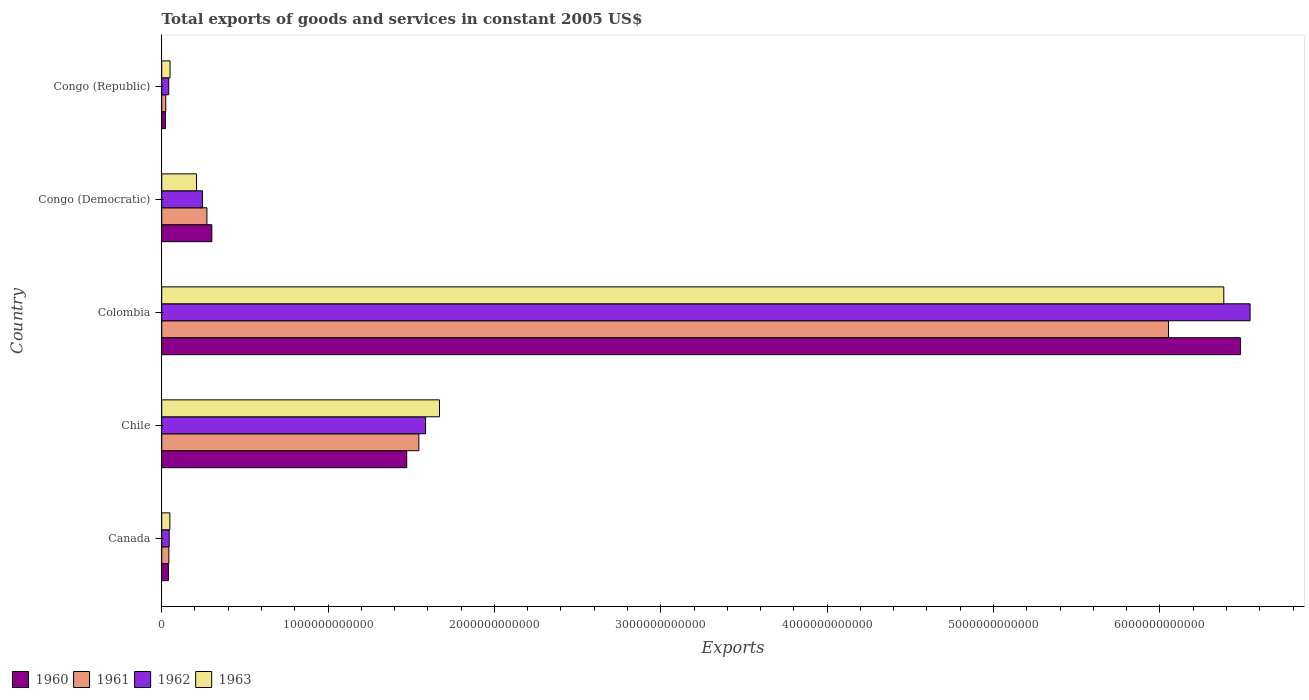How many bars are there on the 1st tick from the bottom?
Make the answer very short. 4. What is the label of the 2nd group of bars from the top?
Keep it short and to the point. Congo (Democratic). In how many cases, is the number of bars for a given country not equal to the number of legend labels?
Your response must be concise. 0. What is the total exports of goods and services in 1961 in Canada?
Your response must be concise. 4.29e+1. Across all countries, what is the maximum total exports of goods and services in 1961?
Keep it short and to the point. 6.05e+12. Across all countries, what is the minimum total exports of goods and services in 1962?
Ensure brevity in your answer.  4.20e+1. In which country was the total exports of goods and services in 1961 maximum?
Provide a short and direct response. Colombia. In which country was the total exports of goods and services in 1963 minimum?
Your answer should be compact. Canada. What is the total total exports of goods and services in 1961 in the graph?
Ensure brevity in your answer.  7.94e+12. What is the difference between the total exports of goods and services in 1963 in Chile and that in Colombia?
Provide a succinct answer. -4.71e+12. What is the difference between the total exports of goods and services in 1960 in Chile and the total exports of goods and services in 1961 in Congo (Republic)?
Offer a terse response. 1.45e+12. What is the average total exports of goods and services in 1960 per country?
Give a very brief answer. 1.66e+12. What is the difference between the total exports of goods and services in 1961 and total exports of goods and services in 1963 in Canada?
Offer a very short reply. -6.12e+09. In how many countries, is the total exports of goods and services in 1962 greater than 4000000000000 US$?
Your answer should be very brief. 1. What is the ratio of the total exports of goods and services in 1960 in Canada to that in Congo (Republic)?
Ensure brevity in your answer.  1.78. Is the total exports of goods and services in 1960 in Chile less than that in Congo (Republic)?
Your answer should be compact. No. What is the difference between the highest and the second highest total exports of goods and services in 1962?
Offer a terse response. 4.96e+12. What is the difference between the highest and the lowest total exports of goods and services in 1963?
Provide a short and direct response. 6.34e+12. In how many countries, is the total exports of goods and services in 1961 greater than the average total exports of goods and services in 1961 taken over all countries?
Ensure brevity in your answer.  1. What does the 2nd bar from the bottom in Congo (Republic) represents?
Offer a terse response. 1961. Are all the bars in the graph horizontal?
Offer a very short reply. Yes. How many countries are there in the graph?
Provide a short and direct response. 5. What is the difference between two consecutive major ticks on the X-axis?
Offer a very short reply. 1.00e+12. Does the graph contain any zero values?
Ensure brevity in your answer.  No. How are the legend labels stacked?
Your answer should be compact. Horizontal. What is the title of the graph?
Ensure brevity in your answer.  Total exports of goods and services in constant 2005 US$. What is the label or title of the X-axis?
Your answer should be compact. Exports. What is the label or title of the Y-axis?
Give a very brief answer. Country. What is the Exports of 1960 in Canada?
Provide a short and direct response. 4.02e+1. What is the Exports of 1961 in Canada?
Your answer should be very brief. 4.29e+1. What is the Exports of 1962 in Canada?
Keep it short and to the point. 4.49e+1. What is the Exports in 1963 in Canada?
Provide a succinct answer. 4.91e+1. What is the Exports of 1960 in Chile?
Your answer should be very brief. 1.47e+12. What is the Exports in 1961 in Chile?
Provide a succinct answer. 1.55e+12. What is the Exports of 1962 in Chile?
Ensure brevity in your answer.  1.59e+12. What is the Exports in 1963 in Chile?
Your answer should be very brief. 1.67e+12. What is the Exports in 1960 in Colombia?
Make the answer very short. 6.48e+12. What is the Exports of 1961 in Colombia?
Offer a terse response. 6.05e+12. What is the Exports of 1962 in Colombia?
Give a very brief answer. 6.54e+12. What is the Exports in 1963 in Colombia?
Ensure brevity in your answer.  6.38e+12. What is the Exports in 1960 in Congo (Democratic)?
Your response must be concise. 3.01e+11. What is the Exports of 1961 in Congo (Democratic)?
Give a very brief answer. 2.72e+11. What is the Exports in 1962 in Congo (Democratic)?
Your answer should be compact. 2.45e+11. What is the Exports of 1963 in Congo (Democratic)?
Offer a terse response. 2.09e+11. What is the Exports of 1960 in Congo (Republic)?
Your response must be concise. 2.25e+1. What is the Exports of 1961 in Congo (Republic)?
Give a very brief answer. 2.42e+1. What is the Exports in 1962 in Congo (Republic)?
Make the answer very short. 4.20e+1. What is the Exports in 1963 in Congo (Republic)?
Provide a succinct answer. 5.01e+1. Across all countries, what is the maximum Exports of 1960?
Keep it short and to the point. 6.48e+12. Across all countries, what is the maximum Exports of 1961?
Make the answer very short. 6.05e+12. Across all countries, what is the maximum Exports of 1962?
Keep it short and to the point. 6.54e+12. Across all countries, what is the maximum Exports of 1963?
Your answer should be very brief. 6.38e+12. Across all countries, what is the minimum Exports in 1960?
Your answer should be very brief. 2.25e+1. Across all countries, what is the minimum Exports of 1961?
Provide a short and direct response. 2.42e+1. Across all countries, what is the minimum Exports of 1962?
Your answer should be very brief. 4.20e+1. Across all countries, what is the minimum Exports in 1963?
Provide a succinct answer. 4.91e+1. What is the total Exports in 1960 in the graph?
Your response must be concise. 8.32e+12. What is the total Exports of 1961 in the graph?
Offer a very short reply. 7.94e+12. What is the total Exports in 1962 in the graph?
Provide a succinct answer. 8.46e+12. What is the total Exports of 1963 in the graph?
Provide a succinct answer. 8.36e+12. What is the difference between the Exports of 1960 in Canada and that in Chile?
Provide a succinct answer. -1.43e+12. What is the difference between the Exports of 1961 in Canada and that in Chile?
Keep it short and to the point. -1.50e+12. What is the difference between the Exports in 1962 in Canada and that in Chile?
Provide a succinct answer. -1.54e+12. What is the difference between the Exports of 1963 in Canada and that in Chile?
Your answer should be compact. -1.62e+12. What is the difference between the Exports of 1960 in Canada and that in Colombia?
Offer a terse response. -6.44e+12. What is the difference between the Exports of 1961 in Canada and that in Colombia?
Your answer should be very brief. -6.01e+12. What is the difference between the Exports in 1962 in Canada and that in Colombia?
Provide a succinct answer. -6.50e+12. What is the difference between the Exports in 1963 in Canada and that in Colombia?
Make the answer very short. -6.34e+12. What is the difference between the Exports of 1960 in Canada and that in Congo (Democratic)?
Your answer should be very brief. -2.61e+11. What is the difference between the Exports in 1961 in Canada and that in Congo (Democratic)?
Your answer should be compact. -2.29e+11. What is the difference between the Exports of 1962 in Canada and that in Congo (Democratic)?
Keep it short and to the point. -2.00e+11. What is the difference between the Exports of 1963 in Canada and that in Congo (Democratic)?
Offer a terse response. -1.60e+11. What is the difference between the Exports in 1960 in Canada and that in Congo (Republic)?
Give a very brief answer. 1.77e+1. What is the difference between the Exports in 1961 in Canada and that in Congo (Republic)?
Your answer should be very brief. 1.87e+1. What is the difference between the Exports in 1962 in Canada and that in Congo (Republic)?
Provide a succinct answer. 2.86e+09. What is the difference between the Exports of 1963 in Canada and that in Congo (Republic)?
Make the answer very short. -1.07e+09. What is the difference between the Exports of 1960 in Chile and that in Colombia?
Keep it short and to the point. -5.01e+12. What is the difference between the Exports in 1961 in Chile and that in Colombia?
Keep it short and to the point. -4.51e+12. What is the difference between the Exports in 1962 in Chile and that in Colombia?
Your response must be concise. -4.96e+12. What is the difference between the Exports in 1963 in Chile and that in Colombia?
Keep it short and to the point. -4.71e+12. What is the difference between the Exports in 1960 in Chile and that in Congo (Democratic)?
Offer a terse response. 1.17e+12. What is the difference between the Exports of 1961 in Chile and that in Congo (Democratic)?
Keep it short and to the point. 1.27e+12. What is the difference between the Exports of 1962 in Chile and that in Congo (Democratic)?
Your answer should be compact. 1.34e+12. What is the difference between the Exports in 1963 in Chile and that in Congo (Democratic)?
Your answer should be very brief. 1.46e+12. What is the difference between the Exports in 1960 in Chile and that in Congo (Republic)?
Offer a terse response. 1.45e+12. What is the difference between the Exports of 1961 in Chile and that in Congo (Republic)?
Provide a succinct answer. 1.52e+12. What is the difference between the Exports in 1962 in Chile and that in Congo (Republic)?
Offer a terse response. 1.54e+12. What is the difference between the Exports in 1963 in Chile and that in Congo (Republic)?
Provide a short and direct response. 1.62e+12. What is the difference between the Exports in 1960 in Colombia and that in Congo (Democratic)?
Ensure brevity in your answer.  6.18e+12. What is the difference between the Exports of 1961 in Colombia and that in Congo (Democratic)?
Provide a succinct answer. 5.78e+12. What is the difference between the Exports of 1962 in Colombia and that in Congo (Democratic)?
Your response must be concise. 6.30e+12. What is the difference between the Exports of 1963 in Colombia and that in Congo (Democratic)?
Ensure brevity in your answer.  6.17e+12. What is the difference between the Exports of 1960 in Colombia and that in Congo (Republic)?
Ensure brevity in your answer.  6.46e+12. What is the difference between the Exports of 1961 in Colombia and that in Congo (Republic)?
Offer a terse response. 6.03e+12. What is the difference between the Exports in 1962 in Colombia and that in Congo (Republic)?
Keep it short and to the point. 6.50e+12. What is the difference between the Exports of 1963 in Colombia and that in Congo (Republic)?
Make the answer very short. 6.33e+12. What is the difference between the Exports of 1960 in Congo (Democratic) and that in Congo (Republic)?
Offer a very short reply. 2.79e+11. What is the difference between the Exports in 1961 in Congo (Democratic) and that in Congo (Republic)?
Make the answer very short. 2.48e+11. What is the difference between the Exports in 1962 in Congo (Democratic) and that in Congo (Republic)?
Ensure brevity in your answer.  2.03e+11. What is the difference between the Exports in 1963 in Congo (Democratic) and that in Congo (Republic)?
Make the answer very short. 1.59e+11. What is the difference between the Exports in 1960 in Canada and the Exports in 1961 in Chile?
Ensure brevity in your answer.  -1.51e+12. What is the difference between the Exports of 1960 in Canada and the Exports of 1962 in Chile?
Ensure brevity in your answer.  -1.55e+12. What is the difference between the Exports in 1960 in Canada and the Exports in 1963 in Chile?
Your response must be concise. -1.63e+12. What is the difference between the Exports of 1961 in Canada and the Exports of 1962 in Chile?
Keep it short and to the point. -1.54e+12. What is the difference between the Exports in 1961 in Canada and the Exports in 1963 in Chile?
Your answer should be very brief. -1.63e+12. What is the difference between the Exports of 1962 in Canada and the Exports of 1963 in Chile?
Give a very brief answer. -1.62e+12. What is the difference between the Exports of 1960 in Canada and the Exports of 1961 in Colombia?
Your answer should be very brief. -6.01e+12. What is the difference between the Exports of 1960 in Canada and the Exports of 1962 in Colombia?
Your answer should be very brief. -6.50e+12. What is the difference between the Exports in 1960 in Canada and the Exports in 1963 in Colombia?
Ensure brevity in your answer.  -6.34e+12. What is the difference between the Exports of 1961 in Canada and the Exports of 1962 in Colombia?
Make the answer very short. -6.50e+12. What is the difference between the Exports in 1961 in Canada and the Exports in 1963 in Colombia?
Offer a very short reply. -6.34e+12. What is the difference between the Exports of 1962 in Canada and the Exports of 1963 in Colombia?
Your response must be concise. -6.34e+12. What is the difference between the Exports of 1960 in Canada and the Exports of 1961 in Congo (Democratic)?
Offer a terse response. -2.32e+11. What is the difference between the Exports of 1960 in Canada and the Exports of 1962 in Congo (Democratic)?
Your response must be concise. -2.05e+11. What is the difference between the Exports of 1960 in Canada and the Exports of 1963 in Congo (Democratic)?
Your answer should be compact. -1.69e+11. What is the difference between the Exports of 1961 in Canada and the Exports of 1962 in Congo (Democratic)?
Your answer should be very brief. -2.02e+11. What is the difference between the Exports of 1961 in Canada and the Exports of 1963 in Congo (Democratic)?
Provide a succinct answer. -1.67e+11. What is the difference between the Exports of 1962 in Canada and the Exports of 1963 in Congo (Democratic)?
Your answer should be very brief. -1.65e+11. What is the difference between the Exports in 1960 in Canada and the Exports in 1961 in Congo (Republic)?
Provide a short and direct response. 1.60e+1. What is the difference between the Exports of 1960 in Canada and the Exports of 1962 in Congo (Republic)?
Your response must be concise. -1.85e+09. What is the difference between the Exports in 1960 in Canada and the Exports in 1963 in Congo (Republic)?
Keep it short and to the point. -9.92e+09. What is the difference between the Exports of 1961 in Canada and the Exports of 1962 in Congo (Republic)?
Your answer should be very brief. 8.81e+08. What is the difference between the Exports in 1961 in Canada and the Exports in 1963 in Congo (Republic)?
Make the answer very short. -7.19e+09. What is the difference between the Exports of 1962 in Canada and the Exports of 1963 in Congo (Republic)?
Provide a succinct answer. -5.21e+09. What is the difference between the Exports of 1960 in Chile and the Exports of 1961 in Colombia?
Your answer should be very brief. -4.58e+12. What is the difference between the Exports of 1960 in Chile and the Exports of 1962 in Colombia?
Keep it short and to the point. -5.07e+12. What is the difference between the Exports of 1960 in Chile and the Exports of 1963 in Colombia?
Offer a terse response. -4.91e+12. What is the difference between the Exports in 1961 in Chile and the Exports in 1962 in Colombia?
Keep it short and to the point. -5.00e+12. What is the difference between the Exports of 1961 in Chile and the Exports of 1963 in Colombia?
Provide a succinct answer. -4.84e+12. What is the difference between the Exports in 1962 in Chile and the Exports in 1963 in Colombia?
Keep it short and to the point. -4.80e+12. What is the difference between the Exports of 1960 in Chile and the Exports of 1961 in Congo (Democratic)?
Give a very brief answer. 1.20e+12. What is the difference between the Exports of 1960 in Chile and the Exports of 1962 in Congo (Democratic)?
Make the answer very short. 1.23e+12. What is the difference between the Exports in 1960 in Chile and the Exports in 1963 in Congo (Democratic)?
Keep it short and to the point. 1.26e+12. What is the difference between the Exports in 1961 in Chile and the Exports in 1962 in Congo (Democratic)?
Your answer should be very brief. 1.30e+12. What is the difference between the Exports of 1961 in Chile and the Exports of 1963 in Congo (Democratic)?
Give a very brief answer. 1.34e+12. What is the difference between the Exports in 1962 in Chile and the Exports in 1963 in Congo (Democratic)?
Offer a very short reply. 1.38e+12. What is the difference between the Exports in 1960 in Chile and the Exports in 1961 in Congo (Republic)?
Provide a succinct answer. 1.45e+12. What is the difference between the Exports of 1960 in Chile and the Exports of 1962 in Congo (Republic)?
Ensure brevity in your answer.  1.43e+12. What is the difference between the Exports of 1960 in Chile and the Exports of 1963 in Congo (Republic)?
Ensure brevity in your answer.  1.42e+12. What is the difference between the Exports of 1961 in Chile and the Exports of 1962 in Congo (Republic)?
Give a very brief answer. 1.50e+12. What is the difference between the Exports in 1961 in Chile and the Exports in 1963 in Congo (Republic)?
Your answer should be very brief. 1.50e+12. What is the difference between the Exports of 1962 in Chile and the Exports of 1963 in Congo (Republic)?
Ensure brevity in your answer.  1.54e+12. What is the difference between the Exports in 1960 in Colombia and the Exports in 1961 in Congo (Democratic)?
Offer a very short reply. 6.21e+12. What is the difference between the Exports of 1960 in Colombia and the Exports of 1962 in Congo (Democratic)?
Your answer should be very brief. 6.24e+12. What is the difference between the Exports of 1960 in Colombia and the Exports of 1963 in Congo (Democratic)?
Your response must be concise. 6.27e+12. What is the difference between the Exports of 1961 in Colombia and the Exports of 1962 in Congo (Democratic)?
Keep it short and to the point. 5.81e+12. What is the difference between the Exports of 1961 in Colombia and the Exports of 1963 in Congo (Democratic)?
Keep it short and to the point. 5.84e+12. What is the difference between the Exports of 1962 in Colombia and the Exports of 1963 in Congo (Democratic)?
Keep it short and to the point. 6.33e+12. What is the difference between the Exports in 1960 in Colombia and the Exports in 1961 in Congo (Republic)?
Keep it short and to the point. 6.46e+12. What is the difference between the Exports of 1960 in Colombia and the Exports of 1962 in Congo (Republic)?
Make the answer very short. 6.44e+12. What is the difference between the Exports in 1960 in Colombia and the Exports in 1963 in Congo (Republic)?
Provide a short and direct response. 6.43e+12. What is the difference between the Exports in 1961 in Colombia and the Exports in 1962 in Congo (Republic)?
Keep it short and to the point. 6.01e+12. What is the difference between the Exports in 1961 in Colombia and the Exports in 1963 in Congo (Republic)?
Your answer should be very brief. 6.00e+12. What is the difference between the Exports of 1962 in Colombia and the Exports of 1963 in Congo (Republic)?
Make the answer very short. 6.49e+12. What is the difference between the Exports of 1960 in Congo (Democratic) and the Exports of 1961 in Congo (Republic)?
Provide a succinct answer. 2.77e+11. What is the difference between the Exports in 1960 in Congo (Democratic) and the Exports in 1962 in Congo (Republic)?
Your response must be concise. 2.59e+11. What is the difference between the Exports in 1960 in Congo (Democratic) and the Exports in 1963 in Congo (Republic)?
Give a very brief answer. 2.51e+11. What is the difference between the Exports in 1961 in Congo (Democratic) and the Exports in 1962 in Congo (Republic)?
Your response must be concise. 2.30e+11. What is the difference between the Exports of 1961 in Congo (Democratic) and the Exports of 1963 in Congo (Republic)?
Offer a very short reply. 2.22e+11. What is the difference between the Exports in 1962 in Congo (Democratic) and the Exports in 1963 in Congo (Republic)?
Make the answer very short. 1.95e+11. What is the average Exports in 1960 per country?
Your answer should be very brief. 1.66e+12. What is the average Exports in 1961 per country?
Your answer should be compact. 1.59e+12. What is the average Exports in 1962 per country?
Give a very brief answer. 1.69e+12. What is the average Exports in 1963 per country?
Provide a short and direct response. 1.67e+12. What is the difference between the Exports of 1960 and Exports of 1961 in Canada?
Provide a short and direct response. -2.73e+09. What is the difference between the Exports of 1960 and Exports of 1962 in Canada?
Give a very brief answer. -4.72e+09. What is the difference between the Exports of 1960 and Exports of 1963 in Canada?
Make the answer very short. -8.86e+09. What is the difference between the Exports of 1961 and Exports of 1962 in Canada?
Your answer should be compact. -1.98e+09. What is the difference between the Exports of 1961 and Exports of 1963 in Canada?
Your answer should be very brief. -6.12e+09. What is the difference between the Exports of 1962 and Exports of 1963 in Canada?
Offer a very short reply. -4.14e+09. What is the difference between the Exports of 1960 and Exports of 1961 in Chile?
Give a very brief answer. -7.28e+1. What is the difference between the Exports in 1960 and Exports in 1962 in Chile?
Make the answer very short. -1.13e+11. What is the difference between the Exports of 1960 and Exports of 1963 in Chile?
Offer a very short reply. -1.97e+11. What is the difference between the Exports of 1961 and Exports of 1962 in Chile?
Your answer should be compact. -4.03e+1. What is the difference between the Exports in 1961 and Exports in 1963 in Chile?
Your answer should be very brief. -1.24e+11. What is the difference between the Exports in 1962 and Exports in 1963 in Chile?
Ensure brevity in your answer.  -8.37e+1. What is the difference between the Exports of 1960 and Exports of 1961 in Colombia?
Your answer should be compact. 4.32e+11. What is the difference between the Exports in 1960 and Exports in 1962 in Colombia?
Offer a terse response. -5.79e+1. What is the difference between the Exports of 1960 and Exports of 1963 in Colombia?
Your answer should be compact. 1.00e+11. What is the difference between the Exports of 1961 and Exports of 1962 in Colombia?
Give a very brief answer. -4.90e+11. What is the difference between the Exports in 1961 and Exports in 1963 in Colombia?
Give a very brief answer. -3.32e+11. What is the difference between the Exports of 1962 and Exports of 1963 in Colombia?
Offer a terse response. 1.58e+11. What is the difference between the Exports in 1960 and Exports in 1961 in Congo (Democratic)?
Ensure brevity in your answer.  2.94e+1. What is the difference between the Exports in 1960 and Exports in 1962 in Congo (Democratic)?
Keep it short and to the point. 5.61e+1. What is the difference between the Exports of 1960 and Exports of 1963 in Congo (Democratic)?
Ensure brevity in your answer.  9.17e+1. What is the difference between the Exports of 1961 and Exports of 1962 in Congo (Democratic)?
Provide a succinct answer. 2.67e+1. What is the difference between the Exports in 1961 and Exports in 1963 in Congo (Democratic)?
Keep it short and to the point. 6.23e+1. What is the difference between the Exports of 1962 and Exports of 1963 in Congo (Democratic)?
Make the answer very short. 3.56e+1. What is the difference between the Exports in 1960 and Exports in 1961 in Congo (Republic)?
Keep it short and to the point. -1.69e+09. What is the difference between the Exports in 1960 and Exports in 1962 in Congo (Republic)?
Make the answer very short. -1.95e+1. What is the difference between the Exports of 1960 and Exports of 1963 in Congo (Republic)?
Keep it short and to the point. -2.76e+1. What is the difference between the Exports of 1961 and Exports of 1962 in Congo (Republic)?
Ensure brevity in your answer.  -1.78e+1. What is the difference between the Exports of 1961 and Exports of 1963 in Congo (Republic)?
Your answer should be very brief. -2.59e+1. What is the difference between the Exports in 1962 and Exports in 1963 in Congo (Republic)?
Provide a succinct answer. -8.07e+09. What is the ratio of the Exports of 1960 in Canada to that in Chile?
Offer a very short reply. 0.03. What is the ratio of the Exports in 1961 in Canada to that in Chile?
Your answer should be very brief. 0.03. What is the ratio of the Exports in 1962 in Canada to that in Chile?
Ensure brevity in your answer.  0.03. What is the ratio of the Exports in 1963 in Canada to that in Chile?
Your answer should be very brief. 0.03. What is the ratio of the Exports of 1960 in Canada to that in Colombia?
Offer a terse response. 0.01. What is the ratio of the Exports of 1961 in Canada to that in Colombia?
Offer a very short reply. 0.01. What is the ratio of the Exports of 1962 in Canada to that in Colombia?
Your response must be concise. 0.01. What is the ratio of the Exports of 1963 in Canada to that in Colombia?
Your response must be concise. 0.01. What is the ratio of the Exports in 1960 in Canada to that in Congo (Democratic)?
Offer a terse response. 0.13. What is the ratio of the Exports in 1961 in Canada to that in Congo (Democratic)?
Provide a short and direct response. 0.16. What is the ratio of the Exports of 1962 in Canada to that in Congo (Democratic)?
Offer a very short reply. 0.18. What is the ratio of the Exports of 1963 in Canada to that in Congo (Democratic)?
Provide a succinct answer. 0.23. What is the ratio of the Exports of 1960 in Canada to that in Congo (Republic)?
Offer a terse response. 1.78. What is the ratio of the Exports in 1961 in Canada to that in Congo (Republic)?
Provide a short and direct response. 1.77. What is the ratio of the Exports in 1962 in Canada to that in Congo (Republic)?
Your answer should be very brief. 1.07. What is the ratio of the Exports in 1963 in Canada to that in Congo (Republic)?
Offer a very short reply. 0.98. What is the ratio of the Exports in 1960 in Chile to that in Colombia?
Keep it short and to the point. 0.23. What is the ratio of the Exports in 1961 in Chile to that in Colombia?
Your answer should be very brief. 0.26. What is the ratio of the Exports of 1962 in Chile to that in Colombia?
Your answer should be compact. 0.24. What is the ratio of the Exports in 1963 in Chile to that in Colombia?
Provide a succinct answer. 0.26. What is the ratio of the Exports in 1960 in Chile to that in Congo (Democratic)?
Offer a terse response. 4.89. What is the ratio of the Exports of 1961 in Chile to that in Congo (Democratic)?
Your answer should be very brief. 5.69. What is the ratio of the Exports of 1962 in Chile to that in Congo (Democratic)?
Provide a short and direct response. 6.47. What is the ratio of the Exports of 1963 in Chile to that in Congo (Democratic)?
Offer a terse response. 7.97. What is the ratio of the Exports in 1960 in Chile to that in Congo (Republic)?
Your answer should be very brief. 65.38. What is the ratio of the Exports in 1961 in Chile to that in Congo (Republic)?
Your response must be concise. 63.82. What is the ratio of the Exports of 1962 in Chile to that in Congo (Republic)?
Provide a short and direct response. 37.72. What is the ratio of the Exports of 1963 in Chile to that in Congo (Republic)?
Your response must be concise. 33.31. What is the ratio of the Exports of 1960 in Colombia to that in Congo (Democratic)?
Your response must be concise. 21.53. What is the ratio of the Exports of 1961 in Colombia to that in Congo (Democratic)?
Make the answer very short. 22.27. What is the ratio of the Exports in 1962 in Colombia to that in Congo (Democratic)?
Offer a terse response. 26.7. What is the ratio of the Exports in 1963 in Colombia to that in Congo (Democratic)?
Make the answer very short. 30.48. What is the ratio of the Exports of 1960 in Colombia to that in Congo (Republic)?
Your answer should be compact. 287.84. What is the ratio of the Exports of 1961 in Colombia to that in Congo (Republic)?
Give a very brief answer. 249.91. What is the ratio of the Exports of 1962 in Colombia to that in Congo (Republic)?
Offer a very short reply. 155.58. What is the ratio of the Exports of 1963 in Colombia to that in Congo (Republic)?
Keep it short and to the point. 127.37. What is the ratio of the Exports of 1960 in Congo (Democratic) to that in Congo (Republic)?
Your response must be concise. 13.37. What is the ratio of the Exports in 1961 in Congo (Democratic) to that in Congo (Republic)?
Provide a succinct answer. 11.22. What is the ratio of the Exports of 1962 in Congo (Democratic) to that in Congo (Republic)?
Give a very brief answer. 5.83. What is the ratio of the Exports in 1963 in Congo (Democratic) to that in Congo (Republic)?
Offer a terse response. 4.18. What is the difference between the highest and the second highest Exports of 1960?
Give a very brief answer. 5.01e+12. What is the difference between the highest and the second highest Exports of 1961?
Your answer should be compact. 4.51e+12. What is the difference between the highest and the second highest Exports of 1962?
Provide a short and direct response. 4.96e+12. What is the difference between the highest and the second highest Exports in 1963?
Make the answer very short. 4.71e+12. What is the difference between the highest and the lowest Exports in 1960?
Your answer should be very brief. 6.46e+12. What is the difference between the highest and the lowest Exports of 1961?
Provide a short and direct response. 6.03e+12. What is the difference between the highest and the lowest Exports in 1962?
Your response must be concise. 6.50e+12. What is the difference between the highest and the lowest Exports in 1963?
Ensure brevity in your answer.  6.34e+12. 